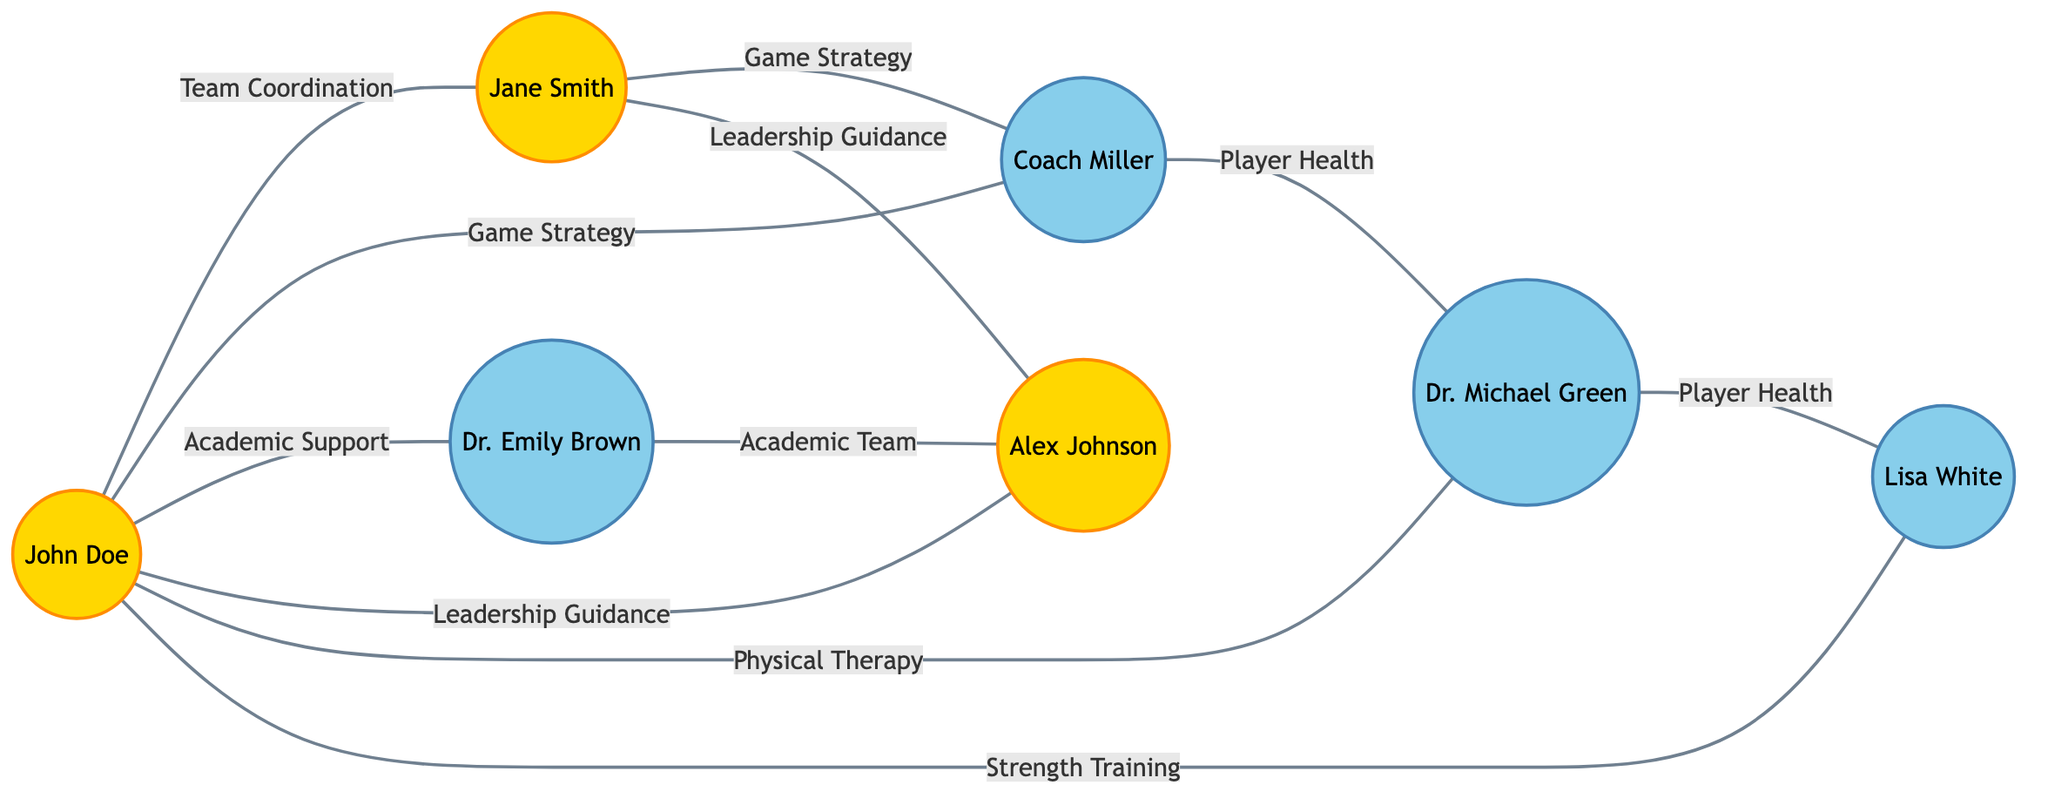What is the label of the node connected to John Doe with team coordination? John Doe is connected to Jane Smith with the label "Team Coordination." Therefore, the label of the node connected to John Doe with this label is "Jane Smith."
Answer: Jane Smith How many edges are connected to Coach Miller? Coach Miller is connected to John Doe, Jane Smith, and Dr. Michael Green, resulting in a total of three edges.
Answer: 3 Who provides academic support to John Doe? The node "Dr. Emily Brown" represents the academic advisor who is linked to John Doe with the label "Academic Support."
Answer: Dr. Emily Brown Identify one relationship between Jane Smith and her teammates. Jane Smith has edges connecting her to Coach Miller and Team Captain Alex Johnson, specifically labeled "Game Strategy" and "Leadership Guidance." Therefore, one relationship is with Coach Miller labeled "Game Strategy."
Answer: Coach Miller (Game Strategy) Which two individuals provide physical support for John Doe? John Doe is connected to Dr. Michael Green and Lisa White, with the relationships labeled "Physical Therapy" and "Strength Training," respectively, indicating both provide physical support.
Answer: Dr. Michael Green and Lisa White Is there a direct connection between the Academic Advisor and Team Captain? There is a direct edge connecting Dr. Emily Brown (Academic Advisor) to Alex Johnson (Team Captain) labeled "Academic Team," confirming there is a direct connection.
Answer: Yes On how many different labels do John Doe and Jane Smith collaborate? John Doe and Jane Smith have the label "Team Coordination" and both also work with Coach Miller under "Game Strategy," making their collaboration on two distinct labels.
Answer: 2 What function does Lisa White serve in relation to the team? Lisa White is connected to John Doe with the label "Strength Training" and also connects to Dr. Michael Green with "Player Health." This indicates her role focuses on strength and health-related support for players.
Answer: Strength Coach Which player receives leadership guidance from Alex Johnson? John Doe and Jane Smith are both connected to Alex Johnson, who offers the label "Leadership Guidance." Thus, both players receive guidance from him.
Answer: John Doe and Jane Smith 